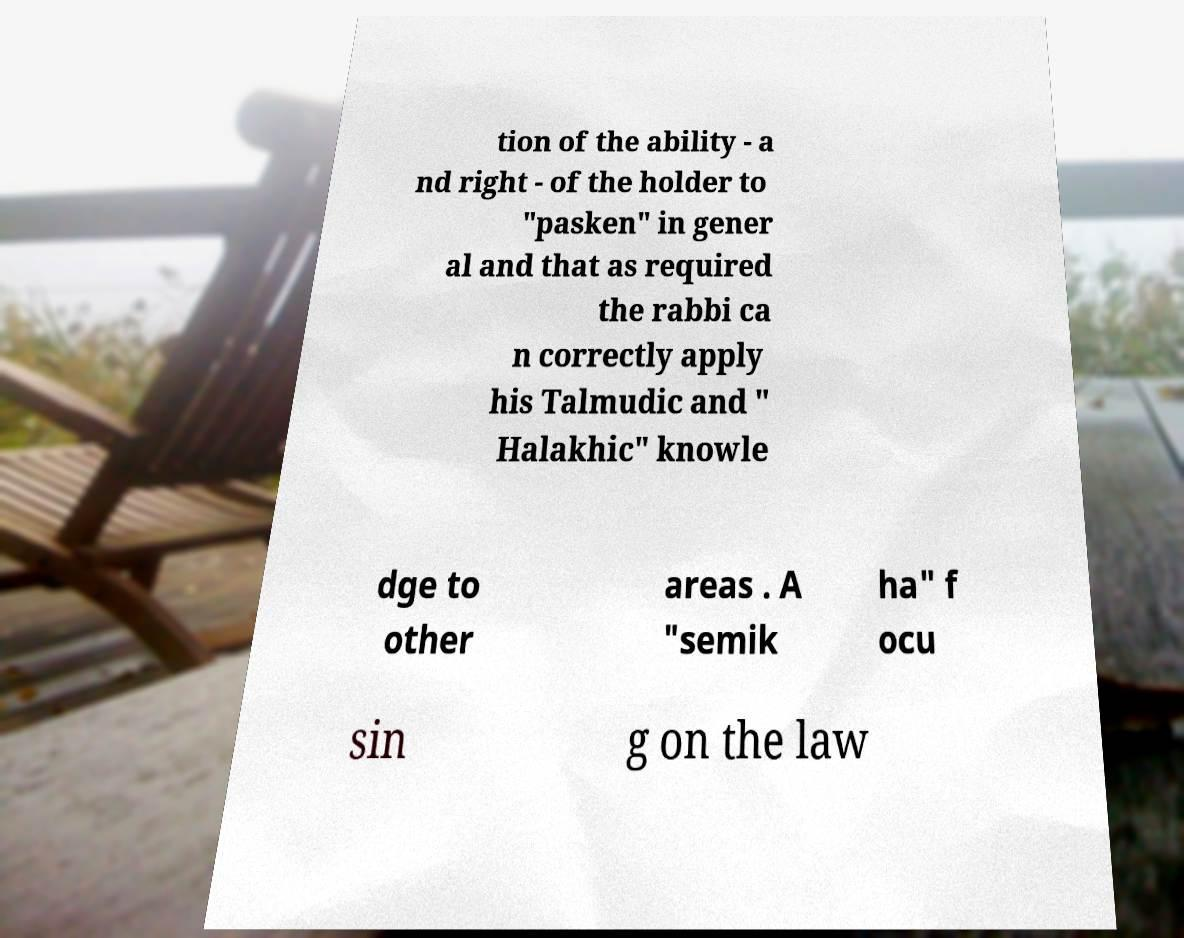Can you accurately transcribe the text from the provided image for me? tion of the ability - a nd right - of the holder to "pasken" in gener al and that as required the rabbi ca n correctly apply his Talmudic and " Halakhic" knowle dge to other areas . A "semik ha" f ocu sin g on the law 